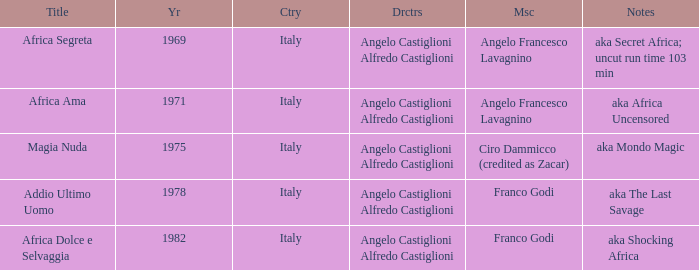What is the country that has a music writer of Angelo Francesco Lavagnino, written in 1969? Italy. 